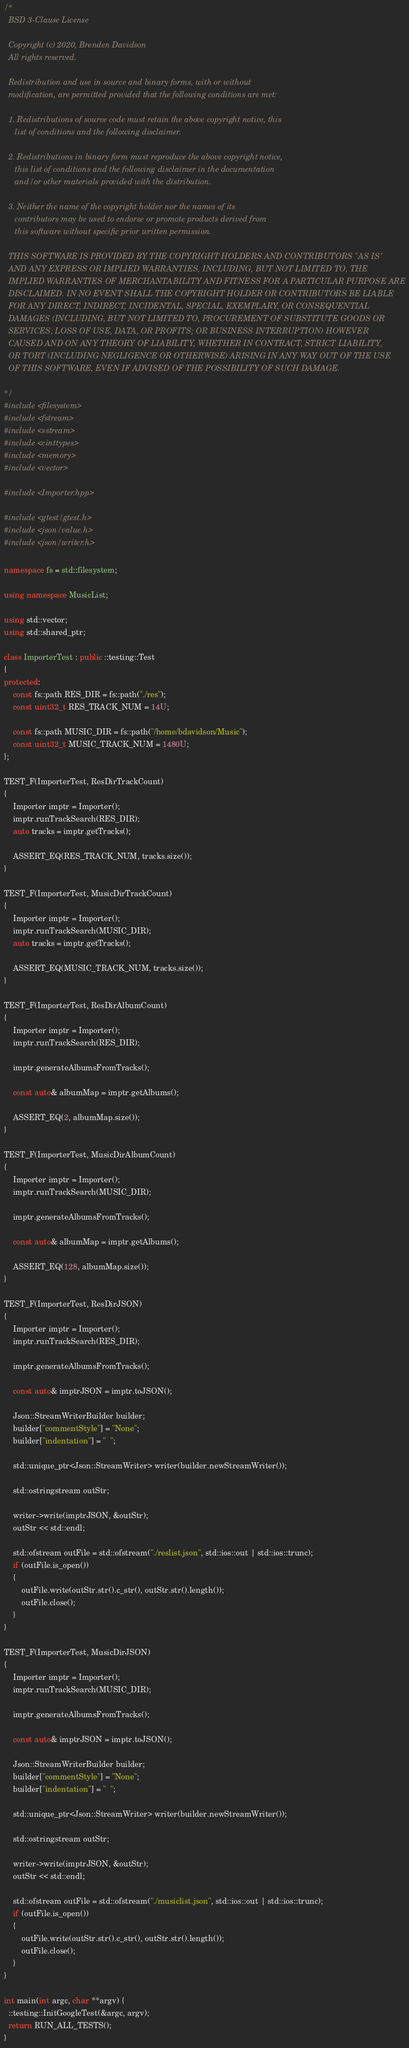Convert code to text. <code><loc_0><loc_0><loc_500><loc_500><_C++_>/*
  BSD 3-Clause License
  
  Copyright (c) 2020, Brenden Davidson
  All rights reserved.
  
  Redistribution and use in source and binary forms, with or without
  modification, are permitted provided that the following conditions are met:
  
  1. Redistributions of source code must retain the above copyright notice, this
     list of conditions and the following disclaimer.
  
  2. Redistributions in binary form must reproduce the above copyright notice,
     this list of conditions and the following disclaimer in the documentation
     and/or other materials provided with the distribution.
  
  3. Neither the name of the copyright holder nor the names of its
     contributors may be used to endorse or promote products derived from
     this software without specific prior written permission.
  
  THIS SOFTWARE IS PROVIDED BY THE COPYRIGHT HOLDERS AND CONTRIBUTORS "AS IS"
  AND ANY EXPRESS OR IMPLIED WARRANTIES, INCLUDING, BUT NOT LIMITED TO, THE
  IMPLIED WARRANTIES OF MERCHANTABILITY AND FITNESS FOR A PARTICULAR PURPOSE ARE
  DISCLAIMED. IN NO EVENT SHALL THE COPYRIGHT HOLDER OR CONTRIBUTORS BE LIABLE
  FOR ANY DIRECT, INDIRECT, INCIDENTAL, SPECIAL, EXEMPLARY, OR CONSEQUENTIAL
  DAMAGES (INCLUDING, BUT NOT LIMITED TO, PROCUREMENT OF SUBSTITUTE GOODS OR
  SERVICES; LOSS OF USE, DATA, OR PROFITS; OR BUSINESS INTERRUPTION) HOWEVER
  CAUSED AND ON ANY THEORY OF LIABILITY, WHETHER IN CONTRACT, STRICT LIABILITY,
  OR TORT (INCLUDING NEGLIGENCE OR OTHERWISE) ARISING IN ANY WAY OUT OF THE USE
  OF THIS SOFTWARE, EVEN IF ADVISED OF THE POSSIBILITY OF SUCH DAMAGE.
  
*/
#include <filesystem>
#include <fstream>
#include <sstream>
#include <cinttypes>
#include <memory>
#include <vector>

#include <Importer.hpp>

#include <gtest/gtest.h>
#include <json/value.h>
#include <json/writer.h>

namespace fs = std::filesystem;

using namespace MusicList;

using std::vector;
using std::shared_ptr;

class ImporterTest : public ::testing::Test
{
protected:
    const fs::path RES_DIR = fs::path("./res");
    const uint32_t RES_TRACK_NUM = 14U;

    const fs::path MUSIC_DIR = fs::path("/home/bdavidson/Music");
    const uint32_t MUSIC_TRACK_NUM = 1480U;
};

TEST_F(ImporterTest, ResDirTrackCount)
{
    Importer imptr = Importer();
    imptr.runTrackSearch(RES_DIR);
    auto tracks = imptr.getTracks();

    ASSERT_EQ(RES_TRACK_NUM, tracks.size());
}

TEST_F(ImporterTest, MusicDirTrackCount)
{
    Importer imptr = Importer();
    imptr.runTrackSearch(MUSIC_DIR);
    auto tracks = imptr.getTracks();

    ASSERT_EQ(MUSIC_TRACK_NUM, tracks.size());
}

TEST_F(ImporterTest, ResDirAlbumCount)
{
    Importer imptr = Importer();
    imptr.runTrackSearch(RES_DIR);

    imptr.generateAlbumsFromTracks();

    const auto& albumMap = imptr.getAlbums();

    ASSERT_EQ(2, albumMap.size());
}

TEST_F(ImporterTest, MusicDirAlbumCount)
{
    Importer imptr = Importer();
    imptr.runTrackSearch(MUSIC_DIR);

    imptr.generateAlbumsFromTracks();

    const auto& albumMap = imptr.getAlbums();

    ASSERT_EQ(128, albumMap.size());
}

TEST_F(ImporterTest, ResDirJSON)
{
    Importer imptr = Importer();
    imptr.runTrackSearch(RES_DIR);

    imptr.generateAlbumsFromTracks();

    const auto& imptrJSON = imptr.toJSON();

    Json::StreamWriterBuilder builder;
    builder["commentStyle"] = "None";
    builder["indentation"] = "  ";

    std::unique_ptr<Json::StreamWriter> writer(builder.newStreamWriter());

    std::ostringstream outStr;

    writer->write(imptrJSON, &outStr);
    outStr << std::endl;

    std::ofstream outFile = std::ofstream("./reslist.json", std::ios::out | std::ios::trunc);
    if (outFile.is_open())
    {
        outFile.write(outStr.str().c_str(), outStr.str().length());
        outFile.close();
    }
}

TEST_F(ImporterTest, MusicDirJSON)
{
    Importer imptr = Importer();
    imptr.runTrackSearch(MUSIC_DIR);

    imptr.generateAlbumsFromTracks();

    const auto& imptrJSON = imptr.toJSON();

    Json::StreamWriterBuilder builder;
    builder["commentStyle"] = "None";
    builder["indentation"] = "  ";

    std::unique_ptr<Json::StreamWriter> writer(builder.newStreamWriter());

    std::ostringstream outStr;

    writer->write(imptrJSON, &outStr);
    outStr << std::endl;

    std::ofstream outFile = std::ofstream("./musiclist.json", std::ios::out | std::ios::trunc);
    if (outFile.is_open())
    {
        outFile.write(outStr.str().c_str(), outStr.str().length());
        outFile.close();
    }
}

int main(int argc, char **argv) {
  ::testing::InitGoogleTest(&argc, argv);
  return RUN_ALL_TESTS();
}
</code> 